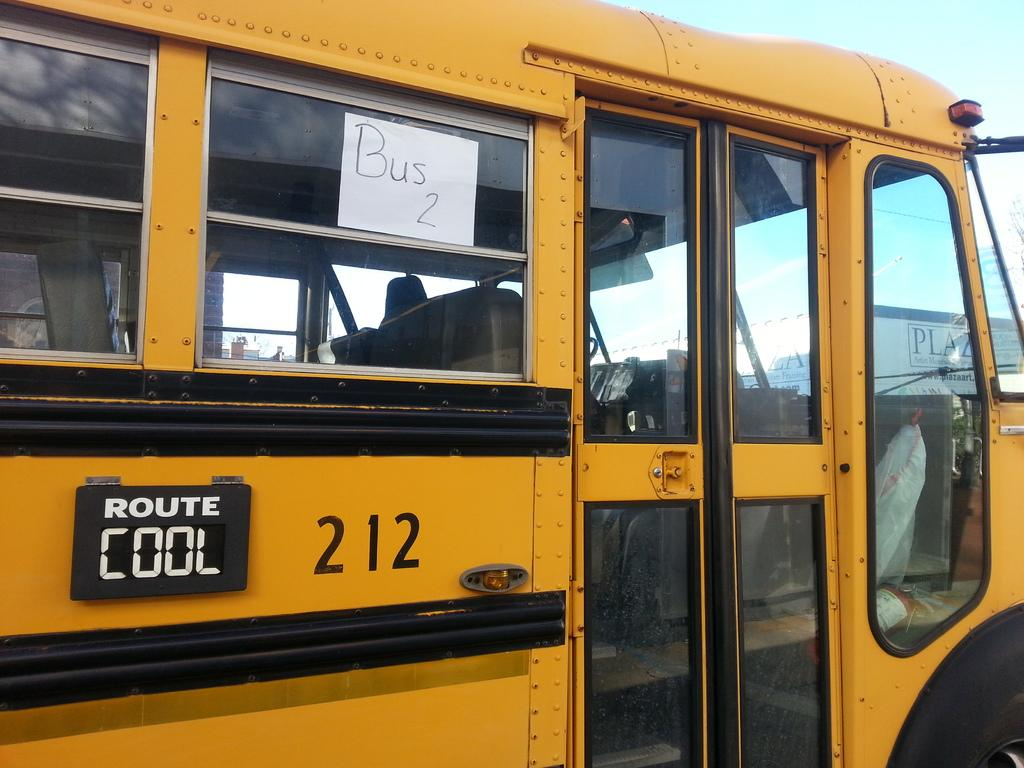<image>
Share a concise interpretation of the image provided. A yellow school bus with the number 212 Route Cool written on the side. 